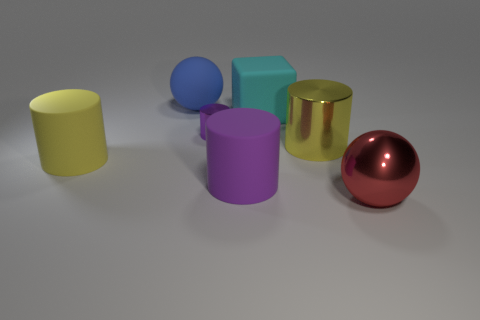Is the size of the cylinder that is right of the matte cube the same as the purple cylinder right of the tiny purple cylinder?
Offer a very short reply. Yes. Are there more purple things that are right of the large blue rubber object than tiny shiny objects that are to the right of the metal sphere?
Give a very brief answer. Yes. Are there any tiny purple cylinders that have the same material as the blue sphere?
Offer a terse response. No. There is a big cylinder that is behind the big purple rubber object and on the right side of the tiny shiny thing; what material is it made of?
Your answer should be very brief. Metal. What is the color of the big metal cylinder?
Offer a terse response. Yellow. What number of large yellow rubber objects are the same shape as the red metal object?
Provide a succinct answer. 0. Does the large sphere that is behind the red sphere have the same material as the yellow cylinder that is to the right of the tiny purple object?
Keep it short and to the point. No. How big is the yellow cylinder left of the yellow cylinder that is right of the large blue matte thing?
Make the answer very short. Large. Is there anything else that is the same size as the purple metal thing?
Make the answer very short. No. What material is the red object that is the same shape as the blue rubber thing?
Ensure brevity in your answer.  Metal. 